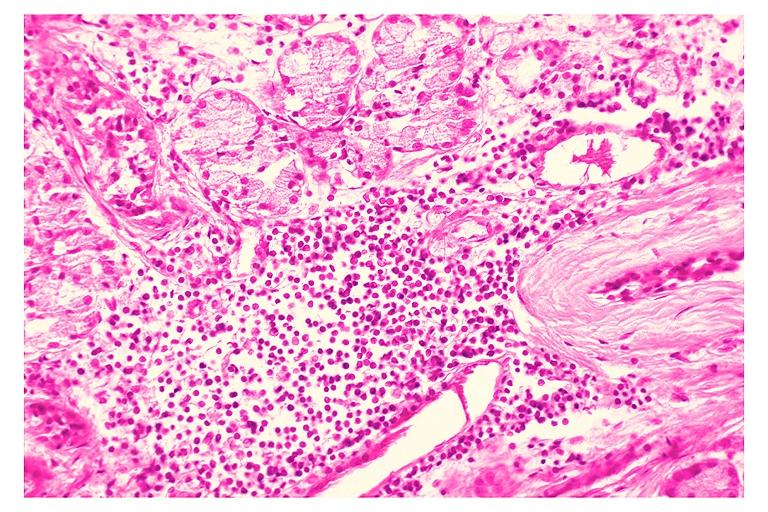s oral present?
Answer the question using a single word or phrase. Yes 